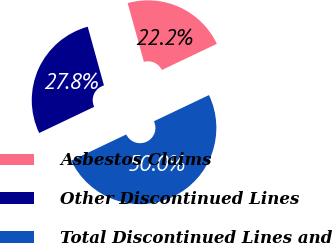Convert chart. <chart><loc_0><loc_0><loc_500><loc_500><pie_chart><fcel>Asbestos Claims<fcel>Other Discontinued Lines<fcel>Total Discontinued Lines and<nl><fcel>22.22%<fcel>27.78%<fcel>50.0%<nl></chart> 